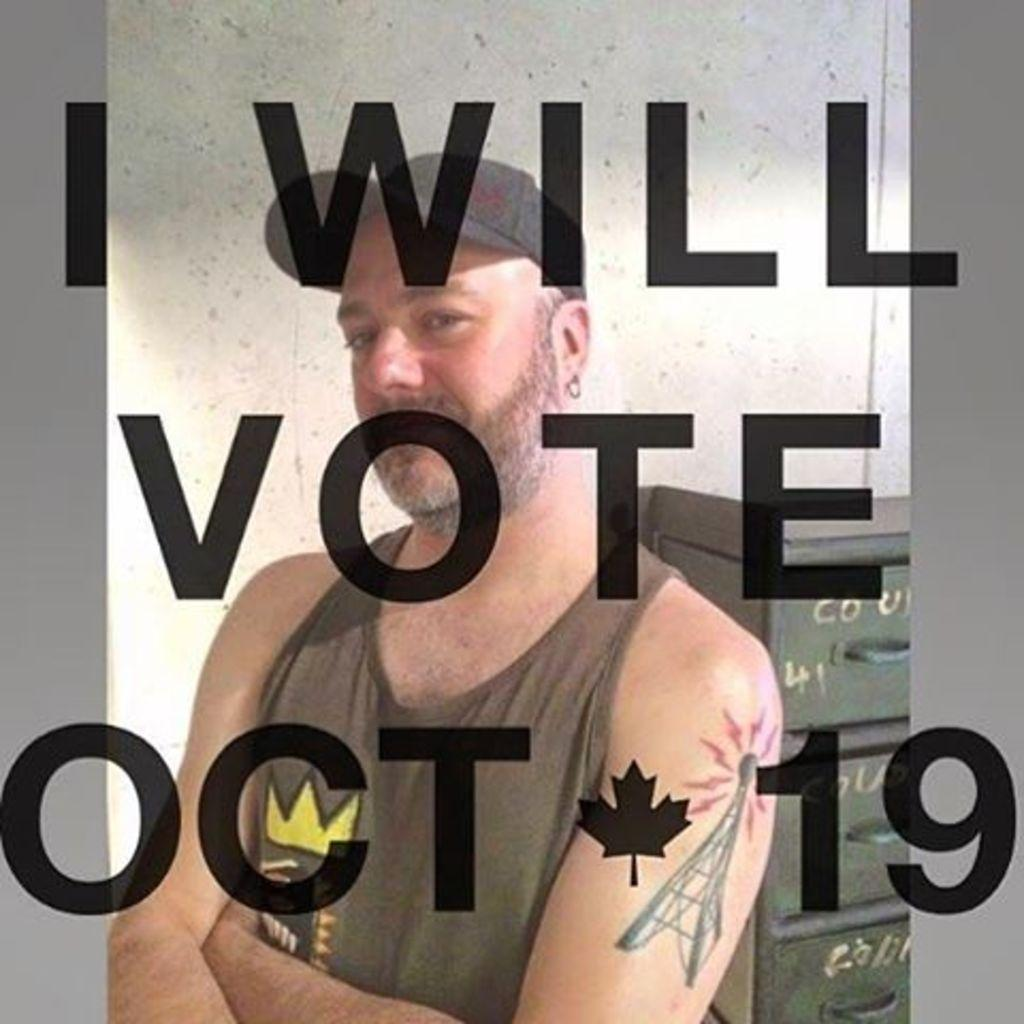What is the main subject of the image? There is a person in the image. What is behind the person in the image? There is a wall behind the person. What can be seen on the right side of the image? There is a rack on the right side of the image. Are there any words or letters visible in the image? Yes, there is some text visible in the image. Can you describe the machine that the bee is using to swim in the lake in the image? There is no machine, bee, or lake present in the image. 